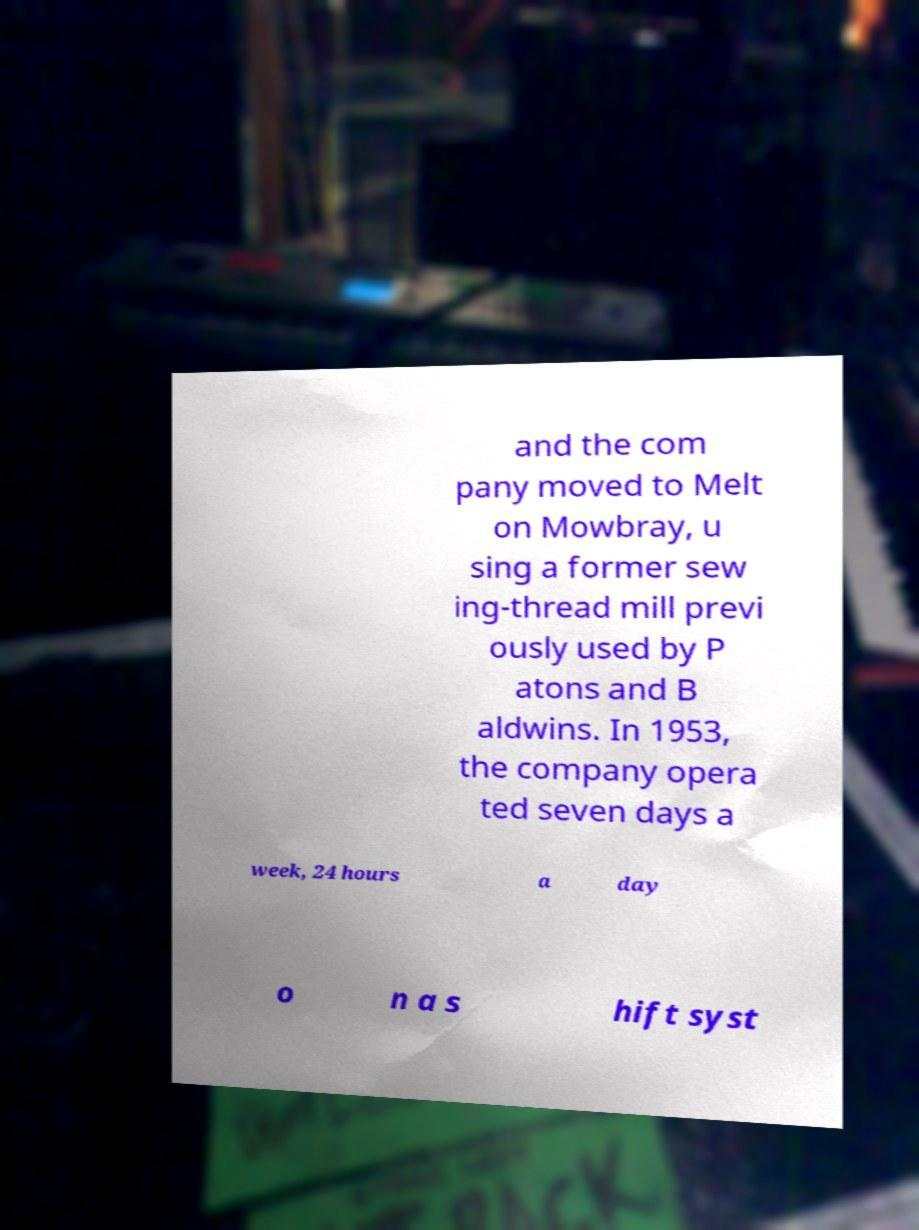Can you accurately transcribe the text from the provided image for me? and the com pany moved to Melt on Mowbray, u sing a former sew ing-thread mill previ ously used by P atons and B aldwins. In 1953, the company opera ted seven days a week, 24 hours a day o n a s hift syst 